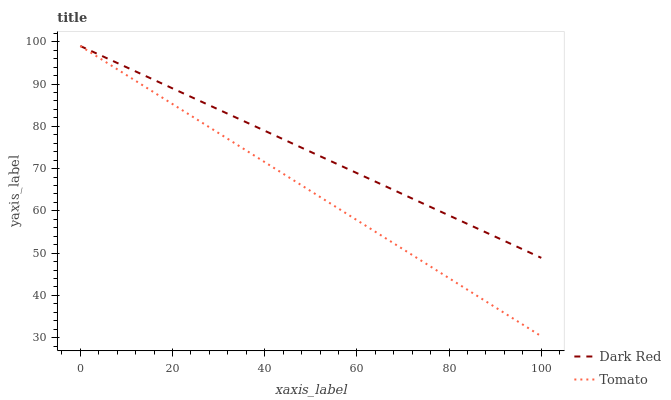Does Tomato have the minimum area under the curve?
Answer yes or no. Yes. Does Dark Red have the maximum area under the curve?
Answer yes or no. Yes. Does Dark Red have the minimum area under the curve?
Answer yes or no. No. Is Dark Red the smoothest?
Answer yes or no. Yes. Is Tomato the roughest?
Answer yes or no. Yes. Is Dark Red the roughest?
Answer yes or no. No. Does Tomato have the lowest value?
Answer yes or no. Yes. Does Dark Red have the lowest value?
Answer yes or no. No. Does Dark Red have the highest value?
Answer yes or no. Yes. Does Tomato intersect Dark Red?
Answer yes or no. Yes. Is Tomato less than Dark Red?
Answer yes or no. No. Is Tomato greater than Dark Red?
Answer yes or no. No. 